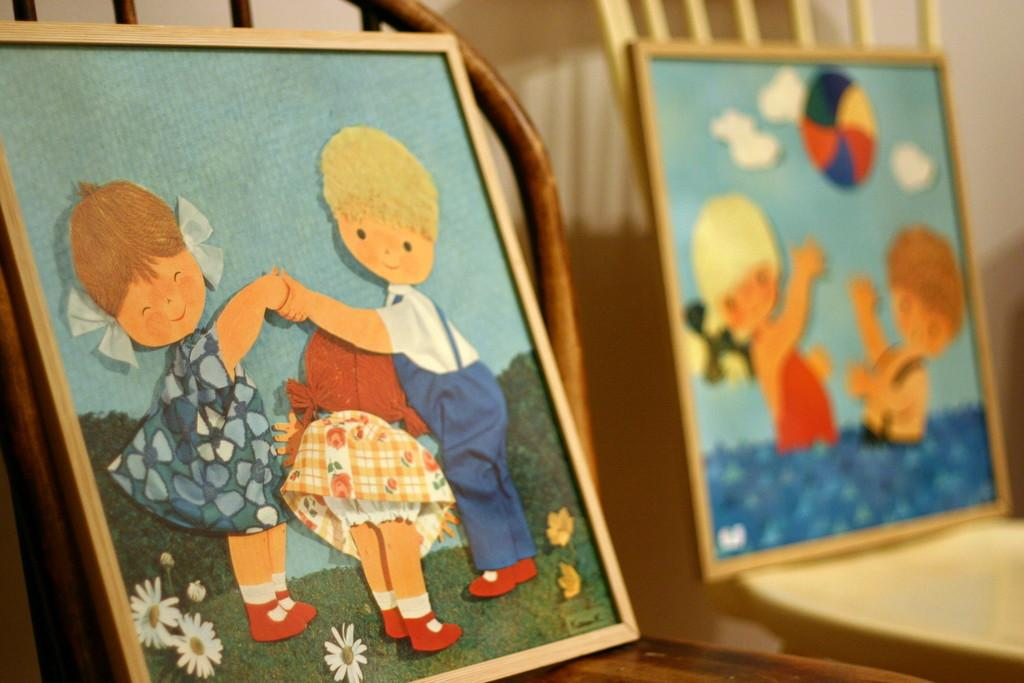What is located in the foreground of the picture? There is a frame in a chair in the foreground of the picture. How would you describe the background of the image? The background of the image is blurred. Are there any other frames in chairs visible in the image? Yes, there is another frame in a chair in the background of the picture. What type of drum can be heard playing in the background of the image? There is no drum or sound present in the image; it is a still photograph. 